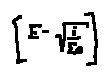Convert formula to latex. <formula><loc_0><loc_0><loc_500><loc_500>[ E - \sqrt { \frac { i } { \sum e } } ]</formula> 